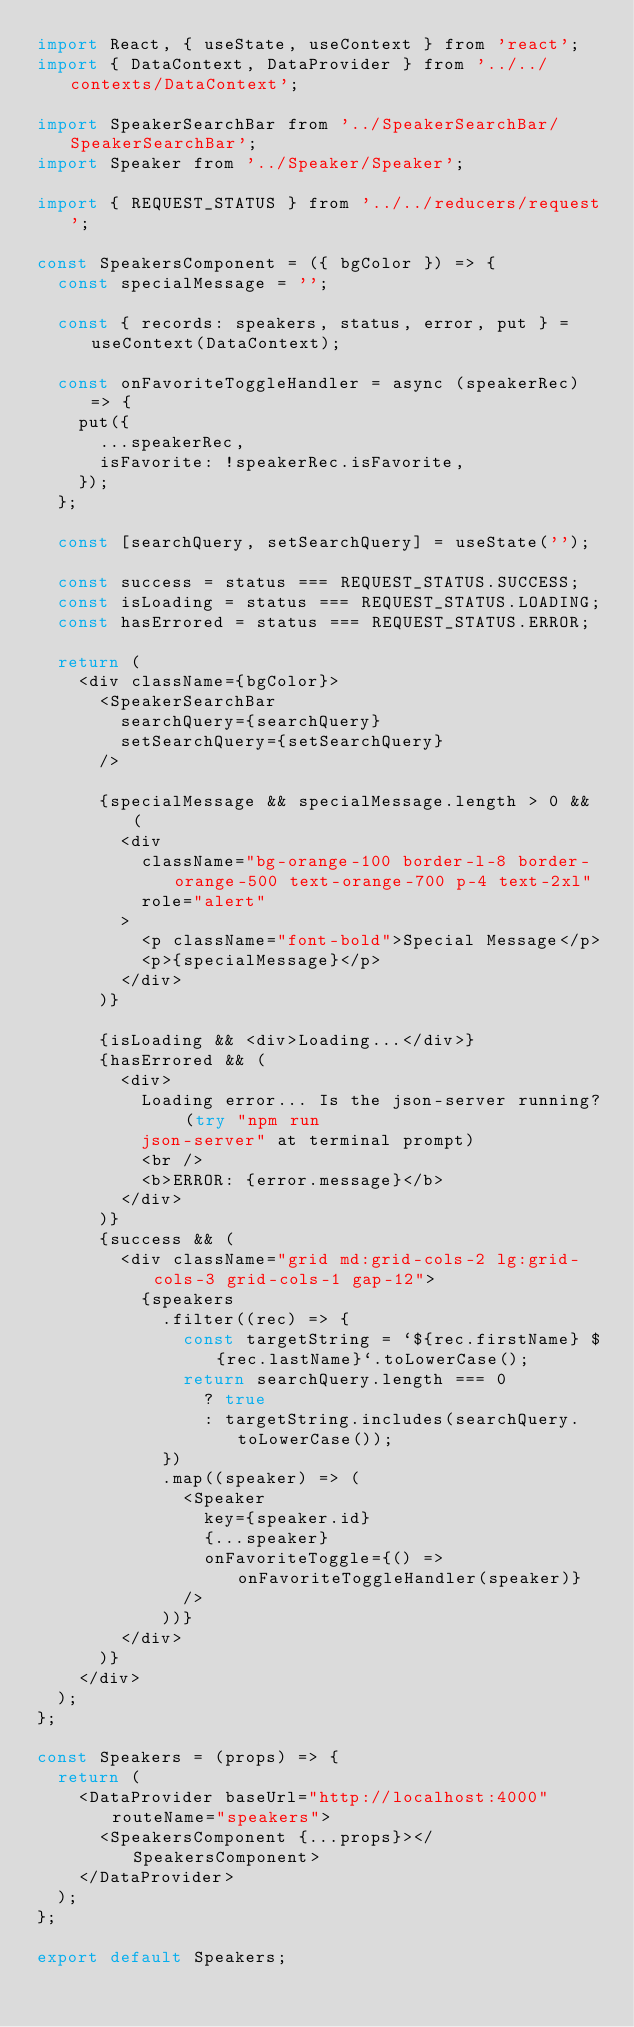Convert code to text. <code><loc_0><loc_0><loc_500><loc_500><_JavaScript_>import React, { useState, useContext } from 'react';
import { DataContext, DataProvider } from '../../contexts/DataContext';

import SpeakerSearchBar from '../SpeakerSearchBar/SpeakerSearchBar';
import Speaker from '../Speaker/Speaker';

import { REQUEST_STATUS } from '../../reducers/request';

const SpeakersComponent = ({ bgColor }) => {
  const specialMessage = '';

  const { records: speakers, status, error, put } = useContext(DataContext);

  const onFavoriteToggleHandler = async (speakerRec) => {
    put({
      ...speakerRec,
      isFavorite: !speakerRec.isFavorite,
    });
  };

  const [searchQuery, setSearchQuery] = useState('');

  const success = status === REQUEST_STATUS.SUCCESS;
  const isLoading = status === REQUEST_STATUS.LOADING;
  const hasErrored = status === REQUEST_STATUS.ERROR;

  return (
    <div className={bgColor}>
      <SpeakerSearchBar
        searchQuery={searchQuery}
        setSearchQuery={setSearchQuery}
      />

      {specialMessage && specialMessage.length > 0 && (
        <div
          className="bg-orange-100 border-l-8 border-orange-500 text-orange-700 p-4 text-2xl"
          role="alert"
        >
          <p className="font-bold">Special Message</p>
          <p>{specialMessage}</p>
        </div>
      )}

      {isLoading && <div>Loading...</div>}
      {hasErrored && (
        <div>
          Loading error... Is the json-server running? (try "npm run
          json-server" at terminal prompt)
          <br />
          <b>ERROR: {error.message}</b>
        </div>
      )}
      {success && (
        <div className="grid md:grid-cols-2 lg:grid-cols-3 grid-cols-1 gap-12">
          {speakers
            .filter((rec) => {
              const targetString = `${rec.firstName} ${rec.lastName}`.toLowerCase();
              return searchQuery.length === 0
                ? true
                : targetString.includes(searchQuery.toLowerCase());
            })
            .map((speaker) => (
              <Speaker
                key={speaker.id}
                {...speaker}
                onFavoriteToggle={() => onFavoriteToggleHandler(speaker)}
              />
            ))}
        </div>
      )}
    </div>
  );
};

const Speakers = (props) => {
  return (
    <DataProvider baseUrl="http://localhost:4000" routeName="speakers">
      <SpeakersComponent {...props}></SpeakersComponent>
    </DataProvider>
  );
};

export default Speakers;
</code> 